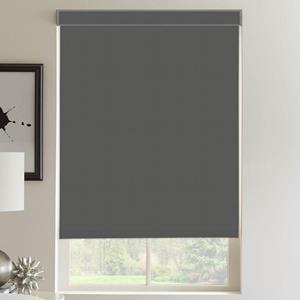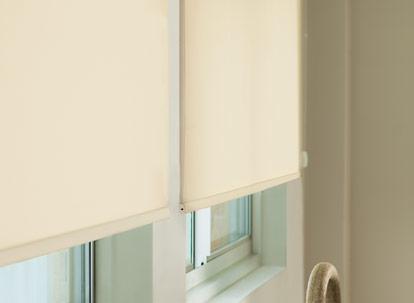The first image is the image on the left, the second image is the image on the right. For the images displayed, is the sentence "There are a total of two windows with white frames shown." factually correct? Answer yes or no. No. 